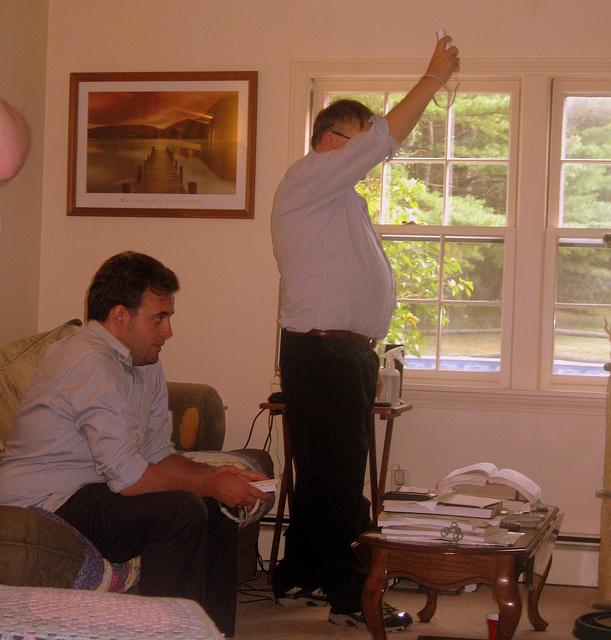What is the man pointing at?
Keep it brief. Ceiling. How many picture frames are seen on the wall?
Be succinct. 1. What is in the picture?
Answer briefly. 2 men. Is there sand on the ground?
Concise answer only. No. What color is the man's shirt in the background?
Give a very brief answer. White. What color is the man wearing?
Concise answer only. White and black. How many people are seated?
Answer briefly. 1. Is it daytime?
Quick response, please. Yes. Does the window have any covering?
Concise answer only. No. What is the man holding?
Concise answer only. Wii controller. How many people can you see?
Answer briefly. 2. Who is barefooted?
Be succinct. No one. Which game player is wearing glasses?
Write a very short answer. 1 standing. What game system are they playing?
Keep it brief. Wii. What is the person doing to the man sitting down?
Short answer required. Nothing. Where is the man sitting?
Answer briefly. Couch. 